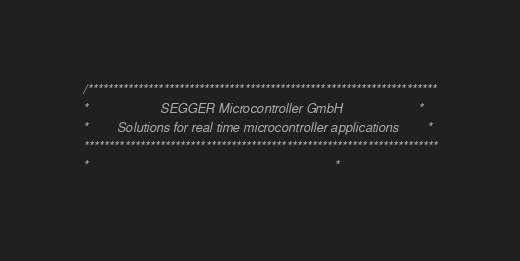<code> <loc_0><loc_0><loc_500><loc_500><_C_>/*********************************************************************
*                    SEGGER Microcontroller GmbH                     *
*        Solutions for real time microcontroller applications        *
**********************************************************************
*                                                                    *</code> 